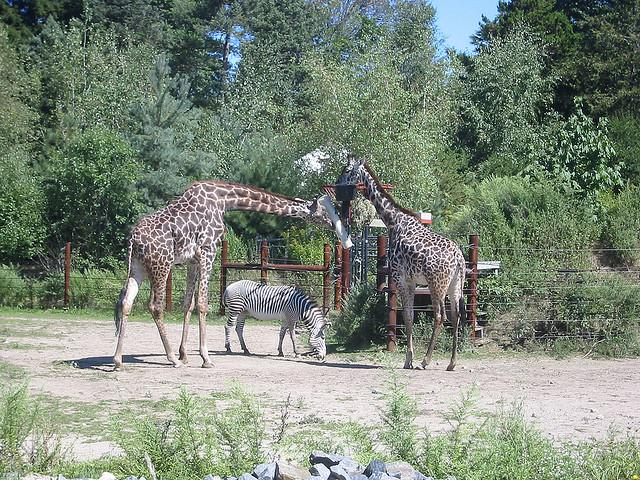What animal is between the giraffes?

Choices:
A) goose
B) cow
C) zebra
D) salamander zebra 